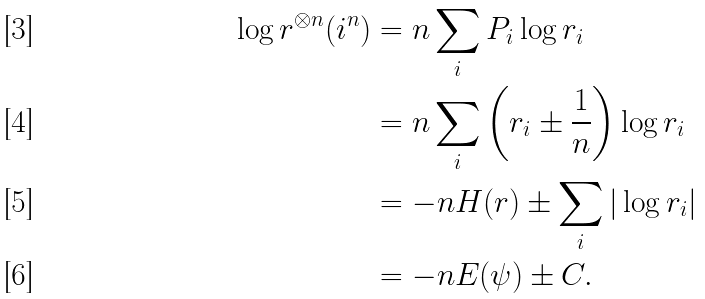<formula> <loc_0><loc_0><loc_500><loc_500>\log r ^ { \otimes n } ( i ^ { n } ) & = n \sum _ { i } P _ { i } \log r _ { i } \\ & = n \sum _ { i } \left ( r _ { i } \pm \frac { 1 } { n } \right ) \log r _ { i } \\ & = - n H ( r ) \pm \sum _ { i } | \log r _ { i } | \\ & = - n E ( \psi ) \pm C .</formula> 